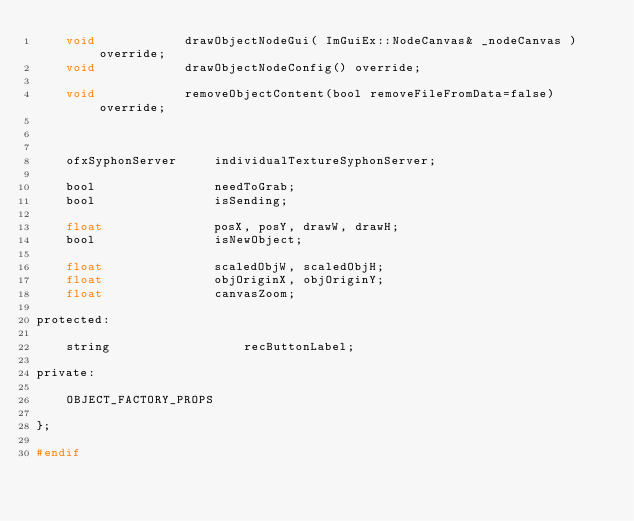Convert code to text. <code><loc_0><loc_0><loc_500><loc_500><_C_>    void            drawObjectNodeGui( ImGuiEx::NodeCanvas& _nodeCanvas ) override;
    void            drawObjectNodeConfig() override;

    void            removeObjectContent(bool removeFileFromData=false) override;



    ofxSyphonServer     individualTextureSyphonServer;

    bool                needToGrab;
    bool                isSending;

    float               posX, posY, drawW, drawH;
    bool                isNewObject;

    float               scaledObjW, scaledObjH;
    float               objOriginX, objOriginY;
    float               canvasZoom;

protected:

    string                  recButtonLabel;

private:

    OBJECT_FACTORY_PROPS

};

#endif
</code> 